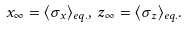<formula> <loc_0><loc_0><loc_500><loc_500>x _ { \infty } = \langle \sigma _ { x } \rangle _ { e q . } , \, z _ { \infty } = \langle \sigma _ { z } \rangle _ { e q . } .</formula> 